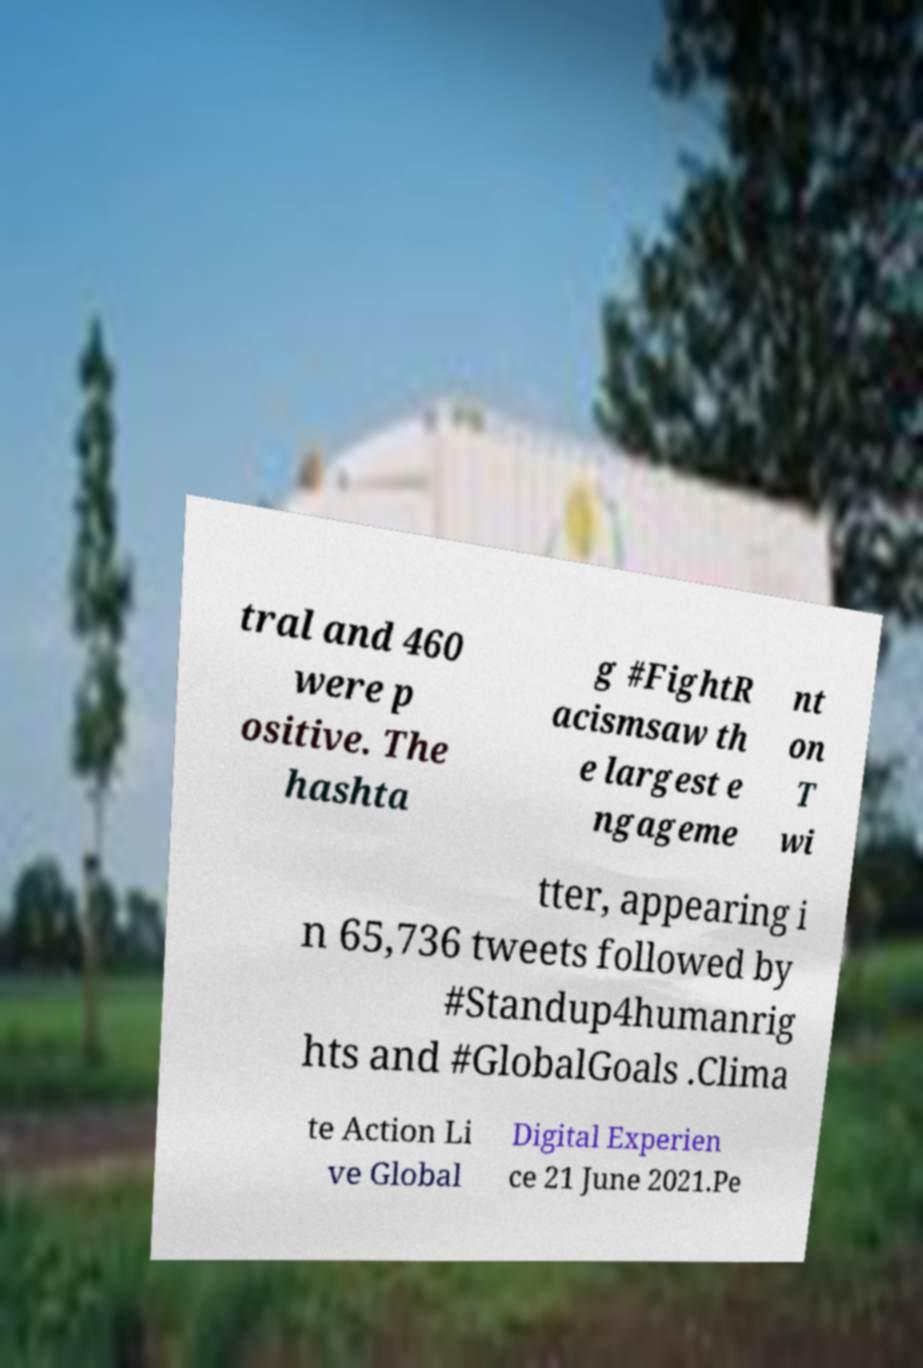Can you read and provide the text displayed in the image?This photo seems to have some interesting text. Can you extract and type it out for me? tral and 460 were p ositive. The hashta g #FightR acismsaw th e largest e ngageme nt on T wi tter, appearing i n 65,736 tweets followed by #Standup4humanrig hts and #GlobalGoals .Clima te Action Li ve Global Digital Experien ce 21 June 2021.Pe 